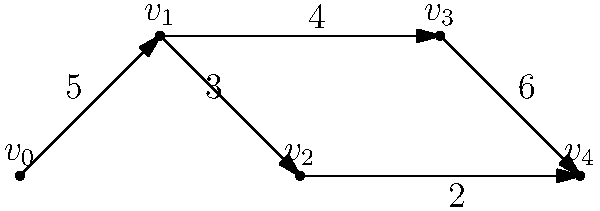Given the directed graph representing a water pipe network, where vertices represent junctions and edges represent pipes with their respective flow rates (in liters per second), what is the maximum flow rate from $v_0$ to $v_4$? To find the maximum flow rate from $v_0$ to $v_4$, we need to use the concept of maximum flow in a network. We can solve this using the Ford-Fulkerson algorithm:

1. Identify all possible paths from $v_0$ to $v_4$:
   Path 1: $v_0 \rightarrow v_1 \rightarrow v_2 \rightarrow v_4$
   Path 2: $v_0 \rightarrow v_1 \rightarrow v_3 \rightarrow v_4$

2. Calculate the flow for each path:
   Path 1: $\min(5, 3, 2) = 2$ liters/second
   Path 2: $\min(5, 4, 6) = 4$ liters/second

3. Sum the flows:
   Total flow = 2 + 4 = 6 liters/second

4. Check if we can augment the flow:
   After using these paths, we have:
   - 3 liters/second unused capacity on $v_0 \rightarrow v_1$
   - 1 liter/second unused capacity on $v_1 \rightarrow v_2$
   - 0 liters/second unused capacity on $v_2 \rightarrow v_4$
   - 0 liters/second unused capacity on $v_1 \rightarrow v_3$
   - 2 liters/second unused capacity on $v_3 \rightarrow v_4$

   There's no augmenting path that can increase the flow, so 6 liters/second is the maximum flow.

Therefore, the maximum flow rate from $v_0$ to $v_4$ is 6 liters per second.
Answer: 6 liters per second 